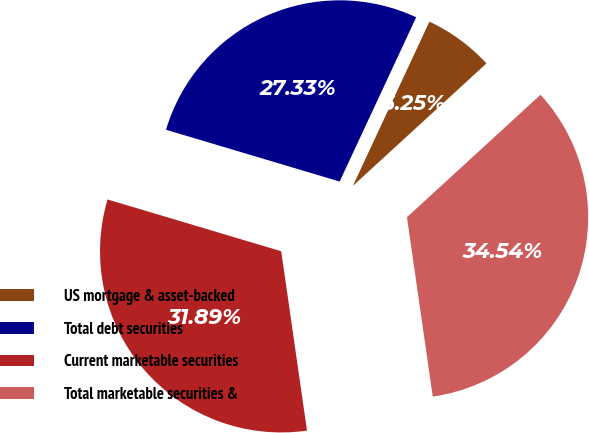Convert chart. <chart><loc_0><loc_0><loc_500><loc_500><pie_chart><fcel>US mortgage & asset-backed<fcel>Total debt securities<fcel>Current marketable securities<fcel>Total marketable securities &<nl><fcel>6.25%<fcel>27.33%<fcel>31.89%<fcel>34.54%<nl></chart> 